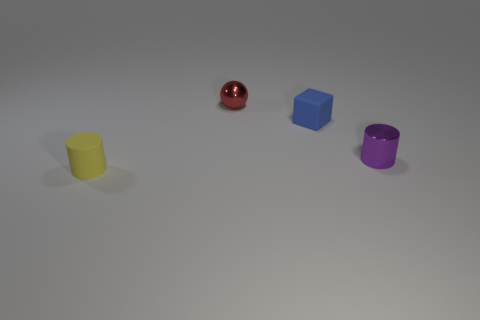Is there any other thing that has the same shape as the tiny blue rubber thing?
Your answer should be very brief. No. Does the tiny block have the same color as the rubber cylinder?
Ensure brevity in your answer.  No. The red thing has what shape?
Provide a short and direct response. Sphere. Are there any other tiny balls that have the same color as the small ball?
Provide a succinct answer. No. Are there more tiny metallic cylinders right of the metal cylinder than small red shiny things?
Offer a terse response. No. Is the shape of the blue matte object the same as the small matte thing in front of the purple metal object?
Your answer should be compact. No. Is there a small blue metal thing?
Offer a terse response. No. What number of small objects are metal things or yellow metal things?
Make the answer very short. 2. Are there more yellow cylinders that are behind the small shiny sphere than tiny matte objects on the right side of the small purple thing?
Make the answer very short. No. Is the material of the blue block the same as the cylinder that is on the right side of the blue object?
Keep it short and to the point. No. 